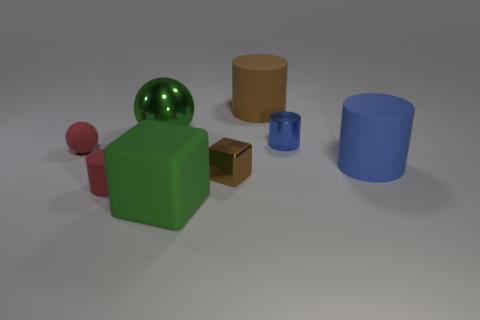Is there any other thing that has the same material as the tiny cube?
Keep it short and to the point. Yes. The tiny rubber thing left of the red matte cylinder is what color?
Provide a succinct answer. Red. Is the number of small rubber balls right of the green rubber cube the same as the number of small brown metallic blocks?
Your answer should be very brief. No. How many other objects are the same shape as the tiny brown object?
Give a very brief answer. 1. How many small metal objects are in front of the big green matte thing?
Ensure brevity in your answer.  0. What size is the object that is behind the matte ball and to the left of the big green matte object?
Provide a succinct answer. Large. Is there a red cylinder?
Provide a succinct answer. Yes. What number of other things are the same size as the red ball?
Your response must be concise. 3. Do the large rubber cylinder that is to the left of the small blue shiny object and the object that is in front of the red rubber cylinder have the same color?
Provide a succinct answer. No. What is the size of the other blue thing that is the same shape as the blue metallic thing?
Offer a terse response. Large. 